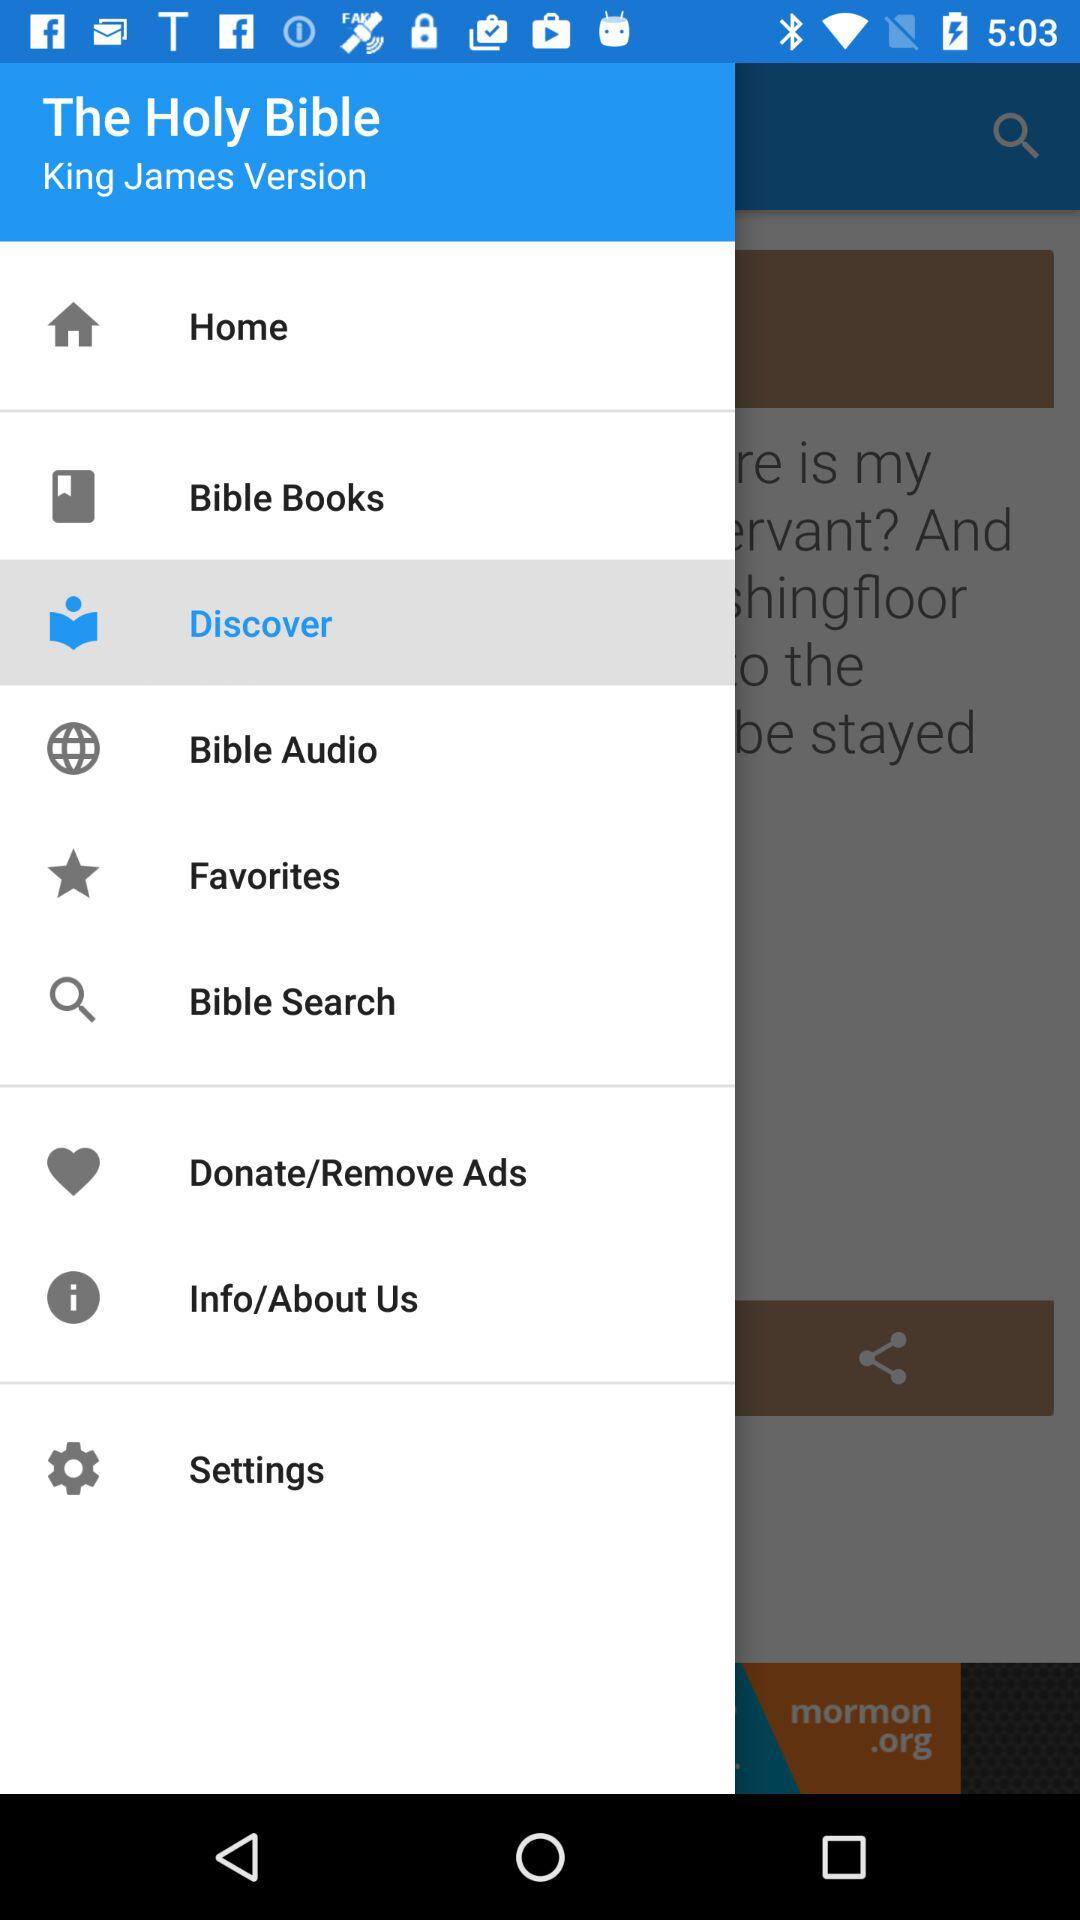Which item has been selected? The item that has been selected is "Discover". 